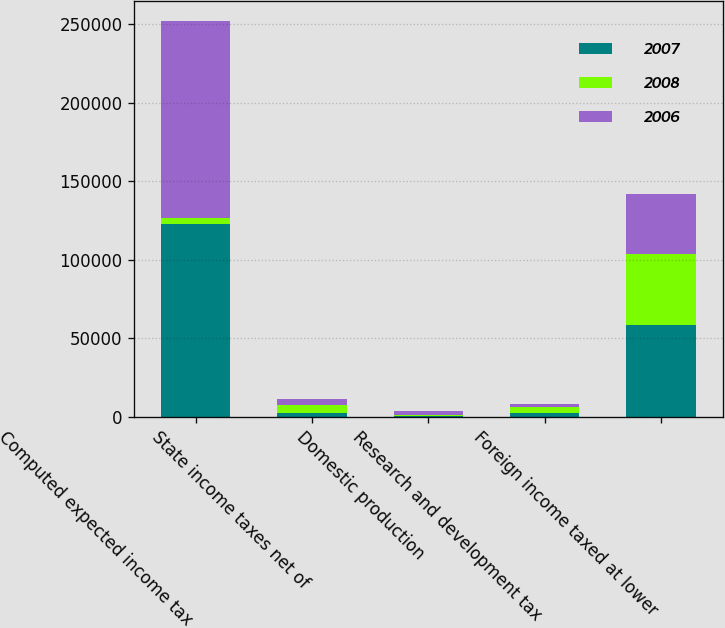<chart> <loc_0><loc_0><loc_500><loc_500><stacked_bar_chart><ecel><fcel>Computed expected income tax<fcel>State income taxes net of<fcel>Domestic production<fcel>Research and development tax<fcel>Foreign income taxed at lower<nl><fcel>2007<fcel>122845<fcel>2727<fcel>257<fcel>2625<fcel>58489<nl><fcel>2008<fcel>3560.5<fcel>5103<fcel>658<fcel>3573<fcel>44993<nl><fcel>2006<fcel>125715<fcel>3548<fcel>2600<fcel>2095<fcel>38362<nl></chart> 